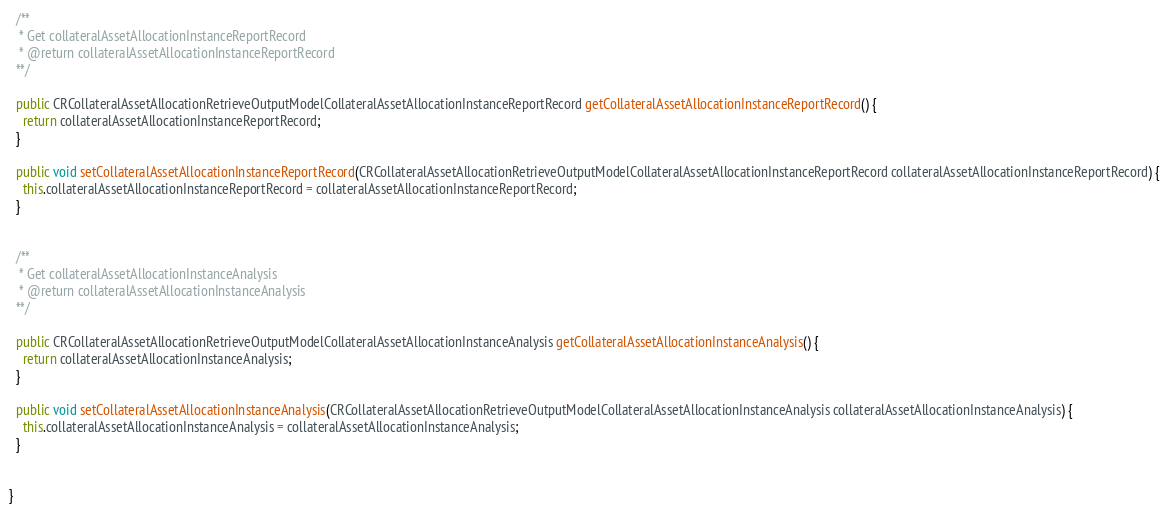Convert code to text. <code><loc_0><loc_0><loc_500><loc_500><_Java_>
  /**
   * Get collateralAssetAllocationInstanceReportRecord
   * @return collateralAssetAllocationInstanceReportRecord
  **/

  public CRCollateralAssetAllocationRetrieveOutputModelCollateralAssetAllocationInstanceReportRecord getCollateralAssetAllocationInstanceReportRecord() {
    return collateralAssetAllocationInstanceReportRecord;
  }

  public void setCollateralAssetAllocationInstanceReportRecord(CRCollateralAssetAllocationRetrieveOutputModelCollateralAssetAllocationInstanceReportRecord collateralAssetAllocationInstanceReportRecord) {
    this.collateralAssetAllocationInstanceReportRecord = collateralAssetAllocationInstanceReportRecord;
  }


  /**
   * Get collateralAssetAllocationInstanceAnalysis
   * @return collateralAssetAllocationInstanceAnalysis
  **/

  public CRCollateralAssetAllocationRetrieveOutputModelCollateralAssetAllocationInstanceAnalysis getCollateralAssetAllocationInstanceAnalysis() {
    return collateralAssetAllocationInstanceAnalysis;
  }

  public void setCollateralAssetAllocationInstanceAnalysis(CRCollateralAssetAllocationRetrieveOutputModelCollateralAssetAllocationInstanceAnalysis collateralAssetAllocationInstanceAnalysis) {
    this.collateralAssetAllocationInstanceAnalysis = collateralAssetAllocationInstanceAnalysis;
  }


}

</code> 